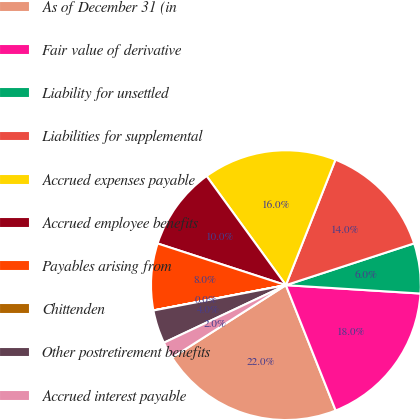Convert chart to OTSL. <chart><loc_0><loc_0><loc_500><loc_500><pie_chart><fcel>As of December 31 (in<fcel>Fair value of derivative<fcel>Liability for unsettled<fcel>Liabilities for supplemental<fcel>Accrued expenses payable<fcel>Accrued employee benefits<fcel>Payables arising from<fcel>Chittenden<fcel>Other postretirement benefits<fcel>Accrued interest payable<nl><fcel>21.99%<fcel>17.99%<fcel>6.0%<fcel>14.0%<fcel>15.99%<fcel>10.0%<fcel>8.0%<fcel>0.01%<fcel>4.01%<fcel>2.01%<nl></chart> 